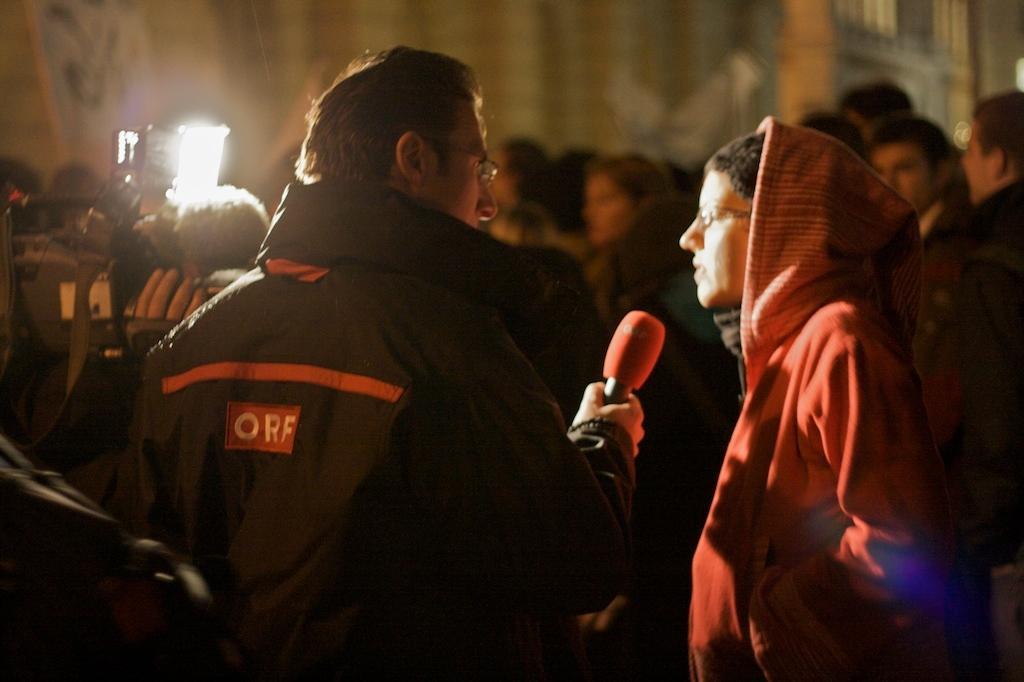Can you describe this image briefly? In this image, there are a few people. Among them, we can see a person holding a microphone and a person holding a video camera. We can also see the blurred background. 